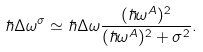<formula> <loc_0><loc_0><loc_500><loc_500>\hbar { \Delta } \omega ^ { \sigma } \simeq \hbar { \Delta } \omega \frac { ( \hbar { \omega } ^ { A } ) ^ { 2 } } { ( \hbar { \omega } ^ { A } ) ^ { 2 } + \sigma ^ { 2 } } .</formula> 